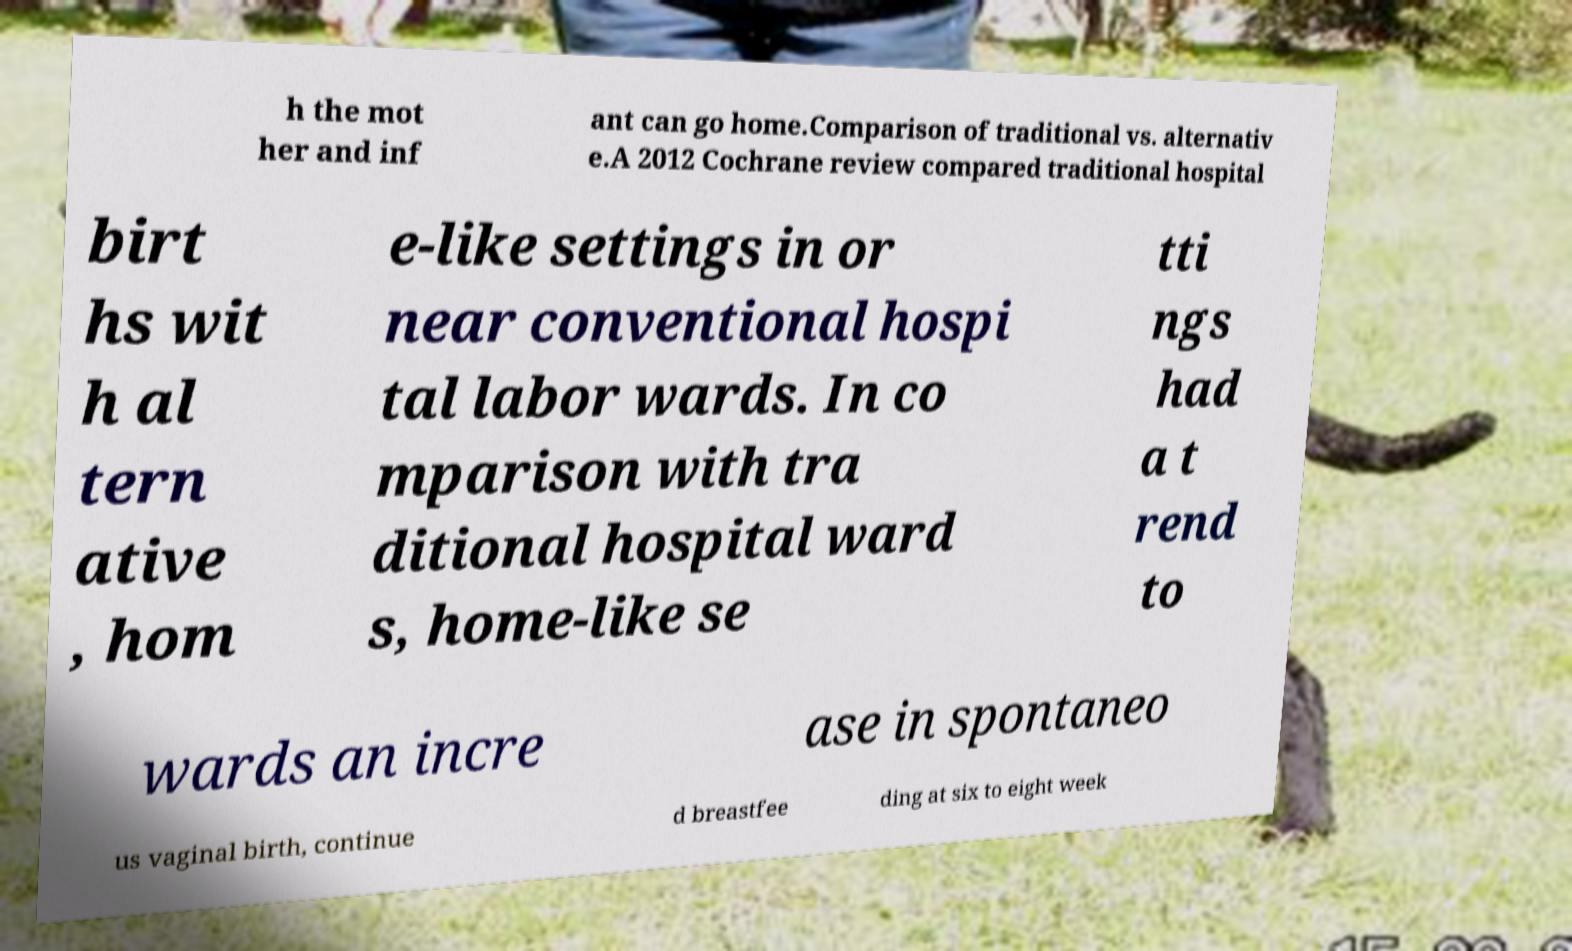Could you assist in decoding the text presented in this image and type it out clearly? h the mot her and inf ant can go home.Comparison of traditional vs. alternativ e.A 2012 Cochrane review compared traditional hospital birt hs wit h al tern ative , hom e-like settings in or near conventional hospi tal labor wards. In co mparison with tra ditional hospital ward s, home-like se tti ngs had a t rend to wards an incre ase in spontaneo us vaginal birth, continue d breastfee ding at six to eight week 